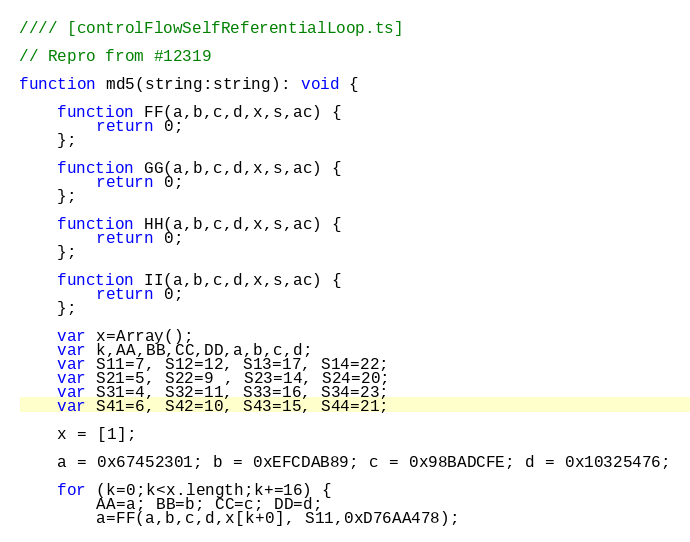Convert code to text. <code><loc_0><loc_0><loc_500><loc_500><_JavaScript_>//// [controlFlowSelfReferentialLoop.ts]

// Repro from #12319

function md5(string:string): void {

    function FF(a,b,c,d,x,s,ac) {
        return 0;
    };

    function GG(a,b,c,d,x,s,ac) {
        return 0;
    };

    function HH(a,b,c,d,x,s,ac) {
        return 0;
    };

    function II(a,b,c,d,x,s,ac) {
        return 0;
    };

    var x=Array();
    var k,AA,BB,CC,DD,a,b,c,d;
    var S11=7, S12=12, S13=17, S14=22;
    var S21=5, S22=9 , S23=14, S24=20;
    var S31=4, S32=11, S33=16, S34=23;
    var S41=6, S42=10, S43=15, S44=21;

    x = [1];

    a = 0x67452301; b = 0xEFCDAB89; c = 0x98BADCFE; d = 0x10325476;

    for (k=0;k<x.length;k+=16) {
        AA=a; BB=b; CC=c; DD=d;
        a=FF(a,b,c,d,x[k+0], S11,0xD76AA478);</code> 